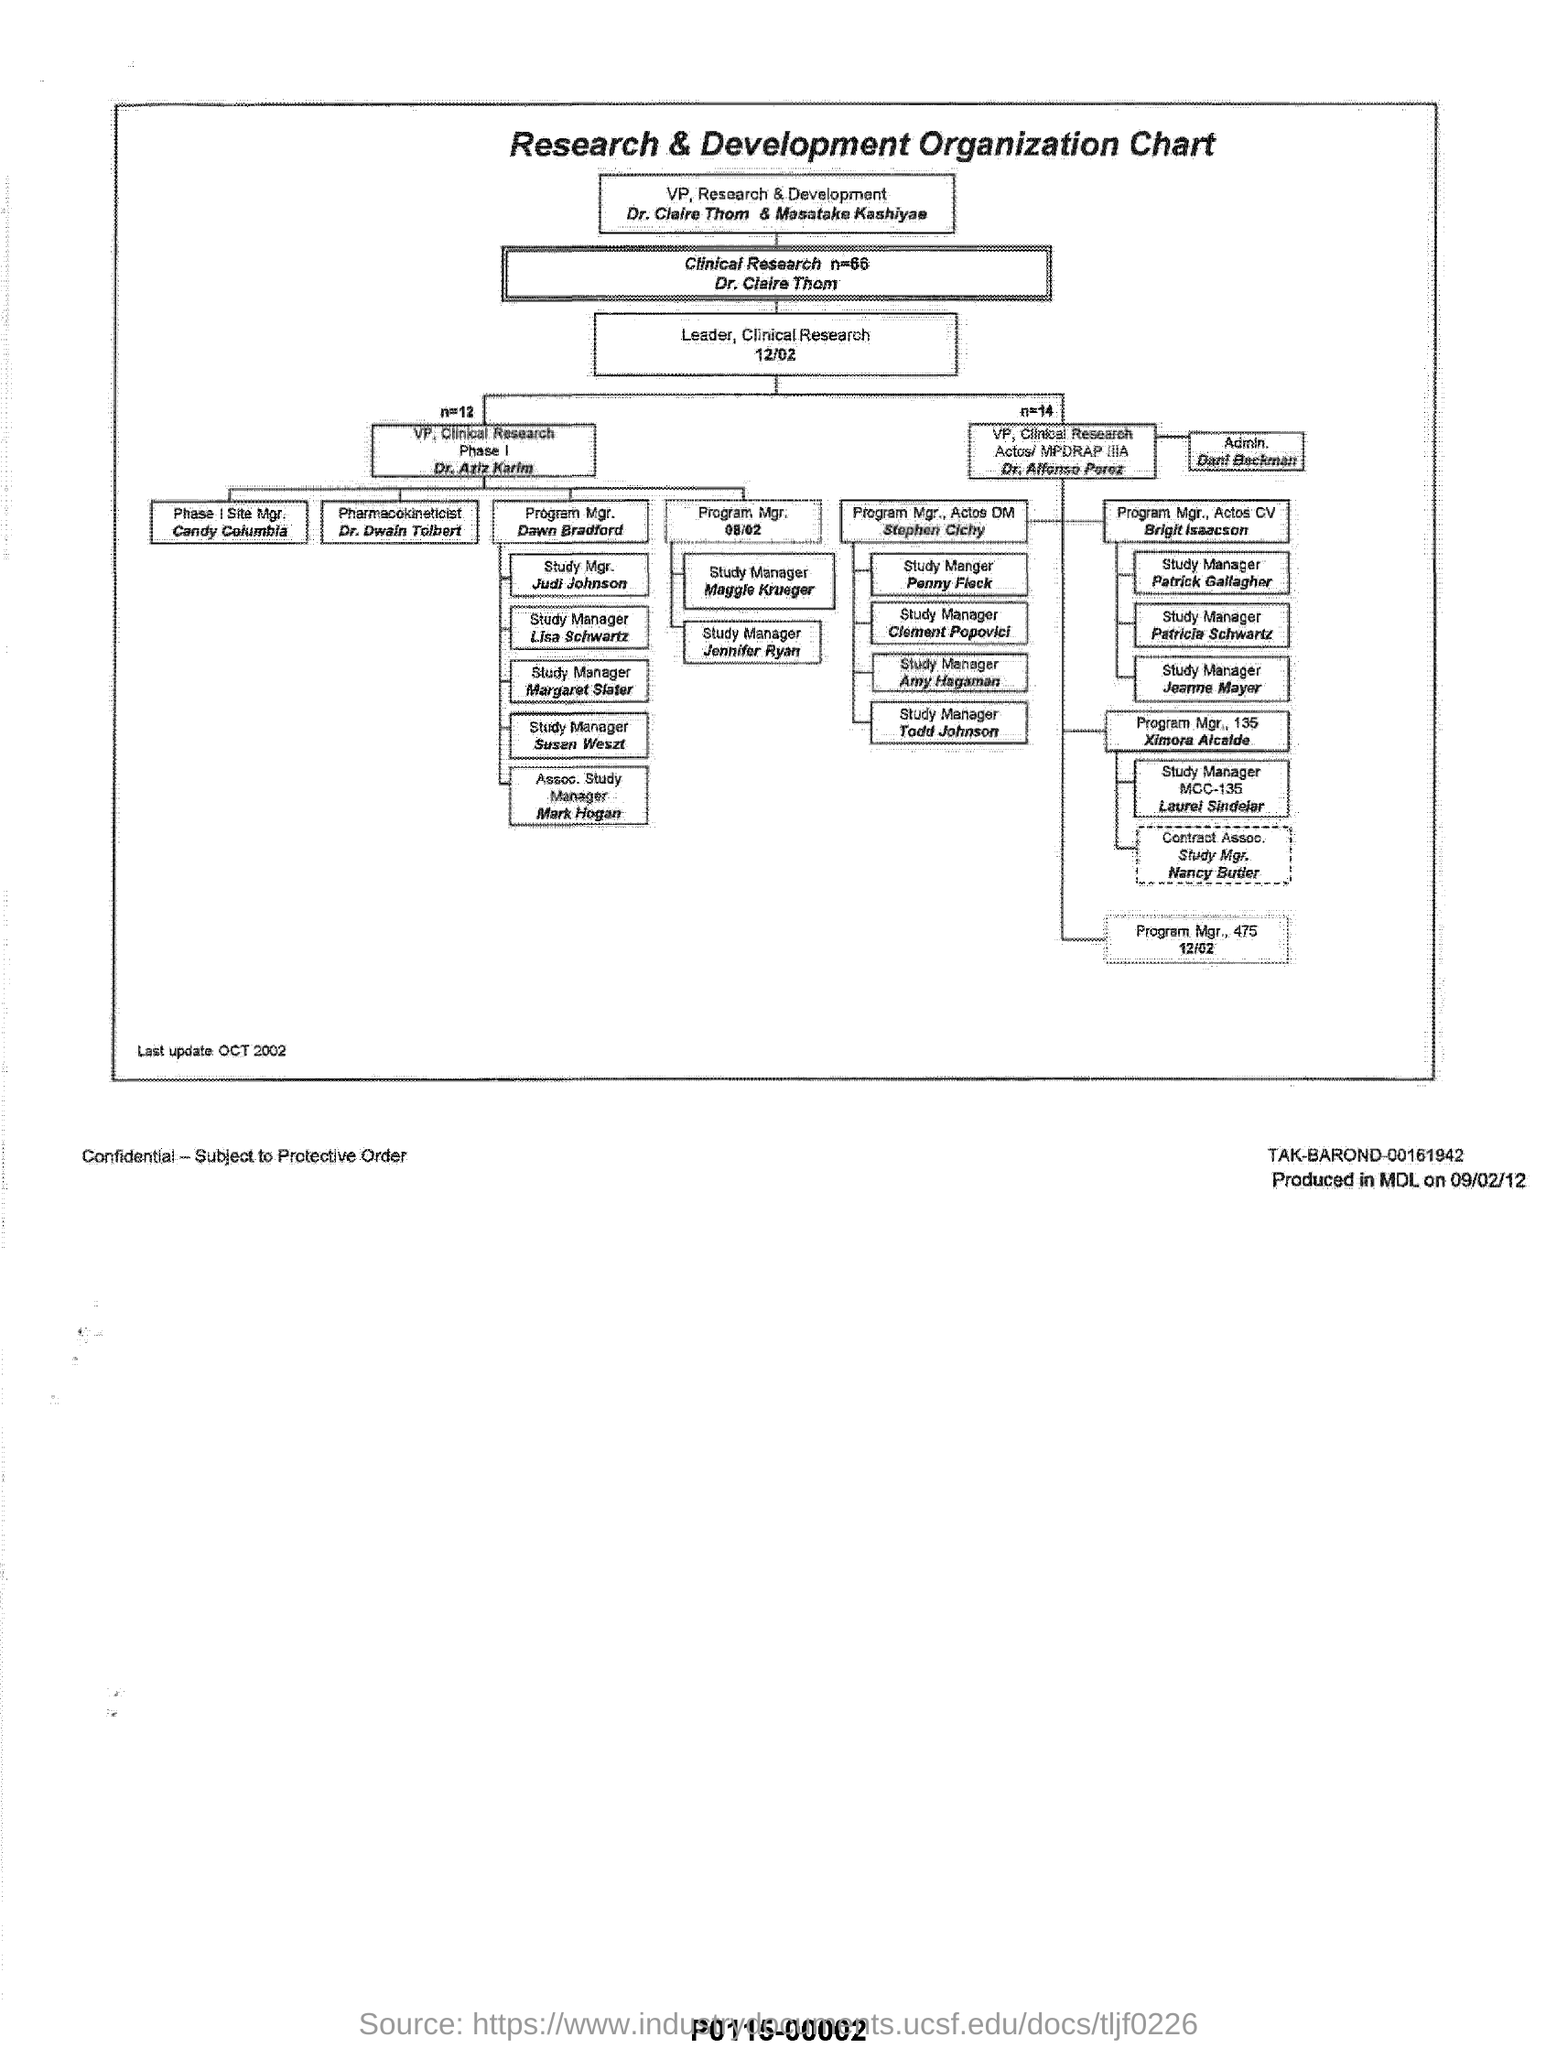Specify some key components in this picture. Dr. Dwain Tolbert holds the title of Pharmacokineticist. The title of the chart is 'Research & Development Organization Chart.' The document was last updated in October 2002. It is Dr. Claire Thom and Masatake Kashiyae who hold the positions of Vice President of Research & Development. 